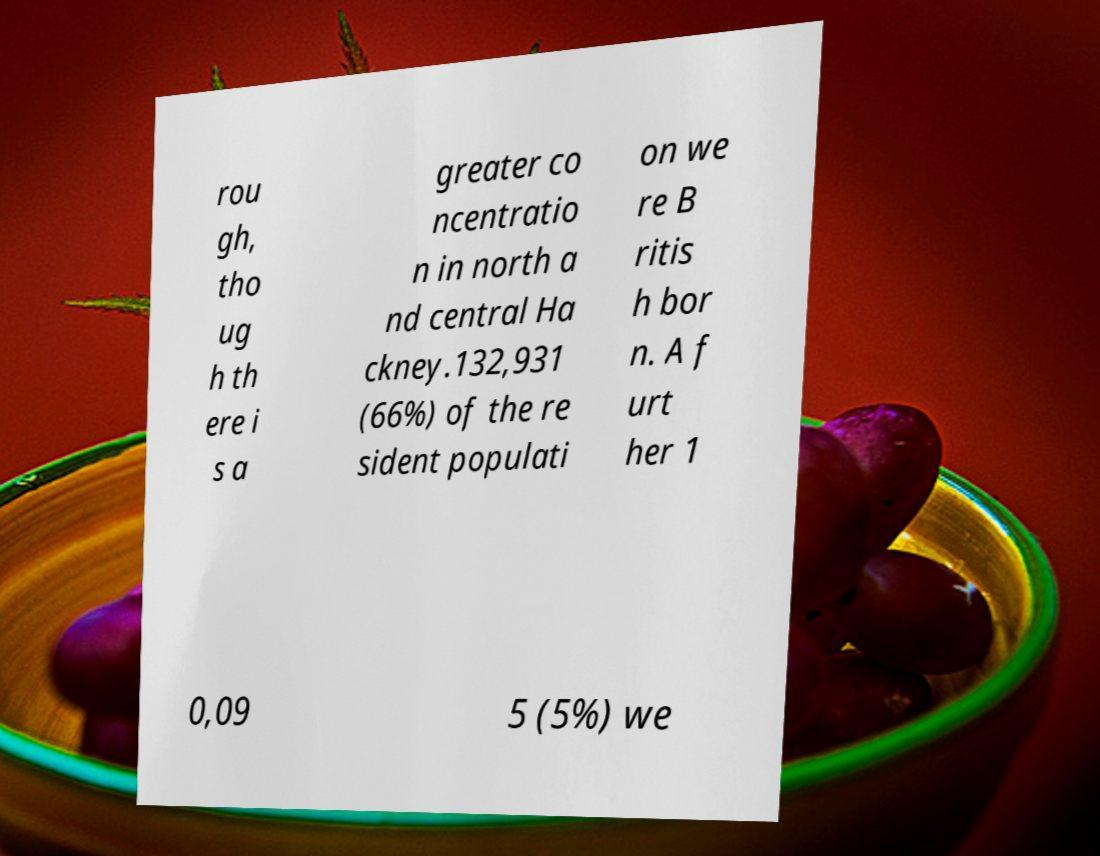Could you assist in decoding the text presented in this image and type it out clearly? rou gh, tho ug h th ere i s a greater co ncentratio n in north a nd central Ha ckney.132,931 (66%) of the re sident populati on we re B ritis h bor n. A f urt her 1 0,09 5 (5%) we 